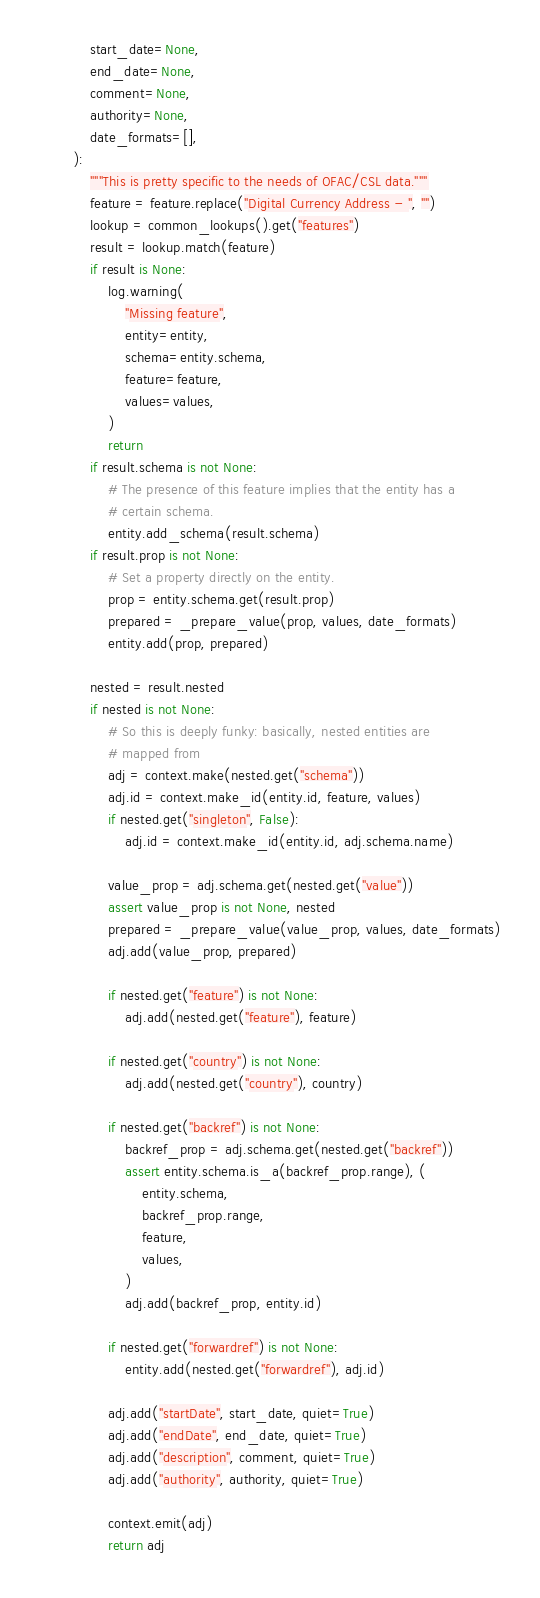<code> <loc_0><loc_0><loc_500><loc_500><_Python_>    start_date=None,
    end_date=None,
    comment=None,
    authority=None,
    date_formats=[],
):
    """This is pretty specific to the needs of OFAC/CSL data."""
    feature = feature.replace("Digital Currency Address - ", "")
    lookup = common_lookups().get("features")
    result = lookup.match(feature)
    if result is None:
        log.warning(
            "Missing feature",
            entity=entity,
            schema=entity.schema,
            feature=feature,
            values=values,
        )
        return
    if result.schema is not None:
        # The presence of this feature implies that the entity has a
        # certain schema.
        entity.add_schema(result.schema)
    if result.prop is not None:
        # Set a property directly on the entity.
        prop = entity.schema.get(result.prop)
        prepared = _prepare_value(prop, values, date_formats)
        entity.add(prop, prepared)

    nested = result.nested
    if nested is not None:
        # So this is deeply funky: basically, nested entities are
        # mapped from
        adj = context.make(nested.get("schema"))
        adj.id = context.make_id(entity.id, feature, values)
        if nested.get("singleton", False):
            adj.id = context.make_id(entity.id, adj.schema.name)

        value_prop = adj.schema.get(nested.get("value"))
        assert value_prop is not None, nested
        prepared = _prepare_value(value_prop, values, date_formats)
        adj.add(value_prop, prepared)

        if nested.get("feature") is not None:
            adj.add(nested.get("feature"), feature)

        if nested.get("country") is not None:
            adj.add(nested.get("country"), country)

        if nested.get("backref") is not None:
            backref_prop = adj.schema.get(nested.get("backref"))
            assert entity.schema.is_a(backref_prop.range), (
                entity.schema,
                backref_prop.range,
                feature,
                values,
            )
            adj.add(backref_prop, entity.id)

        if nested.get("forwardref") is not None:
            entity.add(nested.get("forwardref"), adj.id)

        adj.add("startDate", start_date, quiet=True)
        adj.add("endDate", end_date, quiet=True)
        adj.add("description", comment, quiet=True)
        adj.add("authority", authority, quiet=True)

        context.emit(adj)
        return adj
</code> 